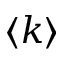<formula> <loc_0><loc_0><loc_500><loc_500>\langle k \rangle</formula> 